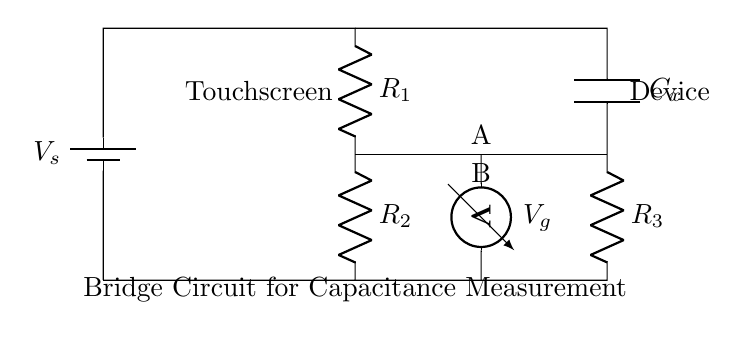What type of circuit is represented? The circuit is a balanced bridge circuit, characterized by its configuration of resistors and a capacitor in a bridge setup used for measuring capacitance.
Answer: balanced bridge circuit What does R1 represent in the circuit? R1 is one of the resistors in the bridge configuration; its value influences the balance condition used for capacitance measurement.
Answer: resistor What component is connected to the voltage source? The voltage source is connected to the first junction of the bridge circuit, which is R1 and R2, providing a potential difference necessary for the operation of the circuit.
Answer: voltage source What is the role of Cx in the circuit? Cx represents the unknown capacitance being measured in the bridge circuit. Its value affects the voltage difference between points A and B.
Answer: unknown capacitance What must the condition be for the bridge to be balanced? The bridge is balanced when the voltage at point A equals the voltage at point B, resulting in zero voltage across the voltmeter.
Answer: zero voltage How many resistors are present in the circuit? There are three resistors (R1, R2, R3) present in the balanced bridge circuit, each contributing to the overall balance and measurement conditions.
Answer: three resistors What do you expect to read on the voltmeter when the bridge is balanced? When the bridge is balanced, the voltmeter reads zero, indicating that there is no potential difference between points A and B due to the cancelled effects of the resistances and capacitance.
Answer: zero 